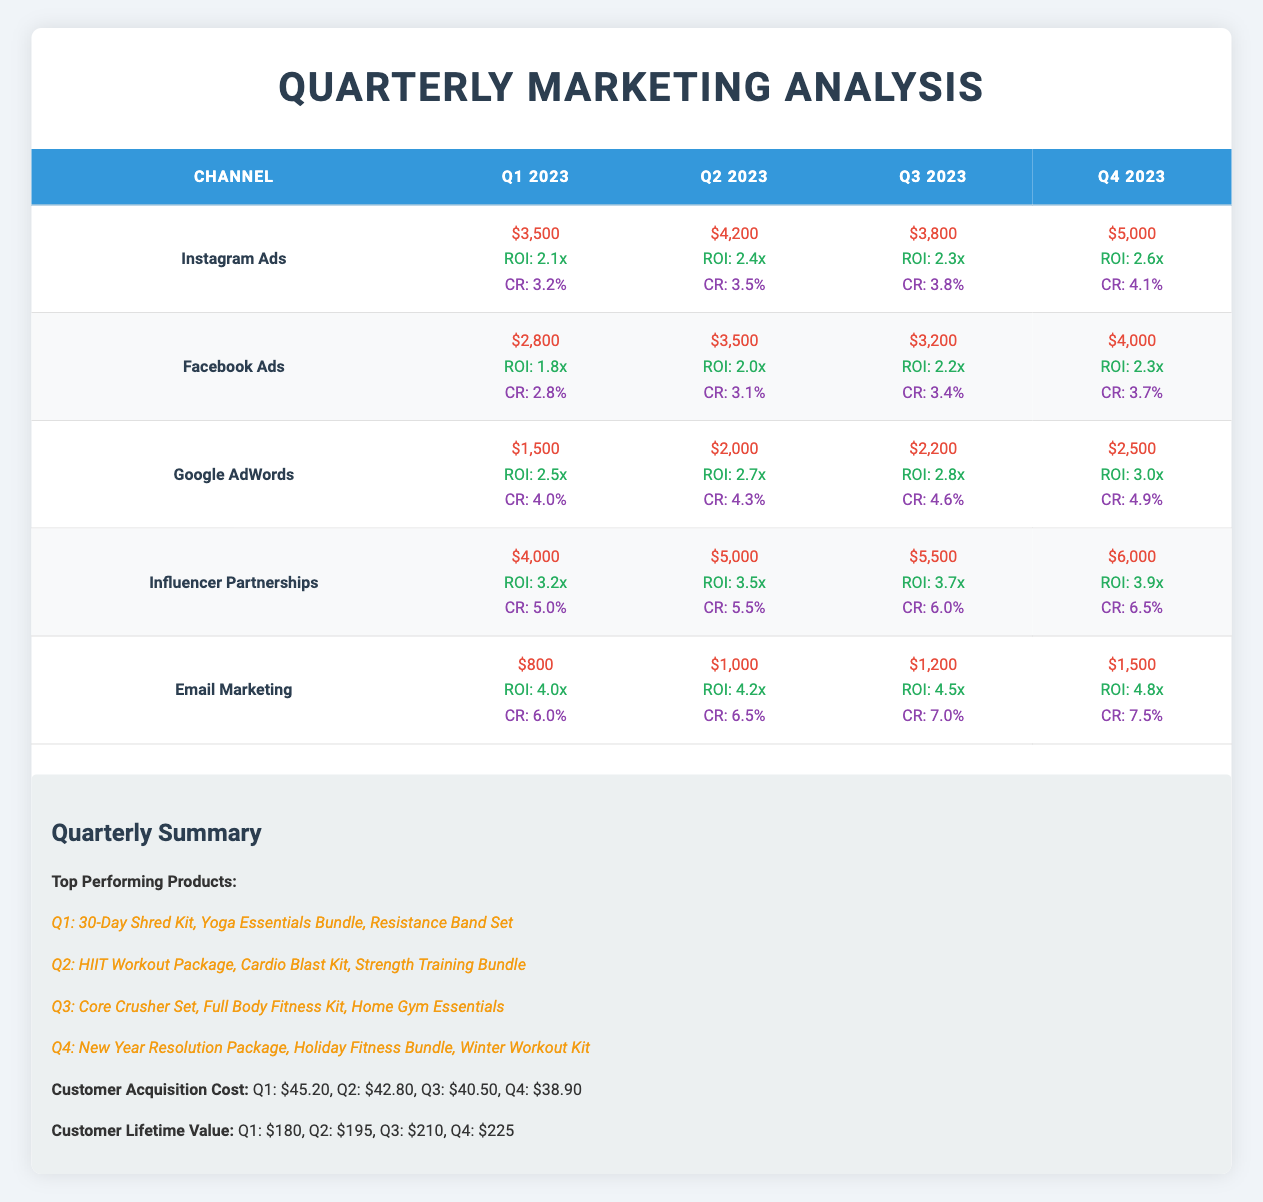What was the highest ROI achieved in Q4 2023 across all marketing channels? The highest ROI in Q4 2023 is found by examining the ROI column for Q4. The values are: Instagram Ads (2.6x), Facebook Ads (2.3x), Google AdWords (3.0x), Influencer Partnerships (3.9x), and Email Marketing (4.8x). The highest value is 4.8x from Email Marketing.
Answer: 4.8x Which marketing channel had the lowest conversion rate in Q1 2023? To find the lowest conversion rate in Q1 2023, we examine the conversion rates: Instagram Ads (3.2%), Facebook Ads (2.8%), Google AdWords (4.0%), Influencer Partnerships (5.0%), and Email Marketing (6.0%). The lowest rate is 2.8% from Facebook Ads.
Answer: 2.8% What is the total marketing expense for Influencer Partnerships over all four quarters? We sum the expenses for Influencer Partnerships: Q1 ($4,000) + Q2 ($5,000) + Q3 ($5,500) + Q4 ($6,000) equals $4,000 + $5,000 + $5,500 + $6,000 = $20,500.
Answer: $20,500 Did the customer acquisition cost decrease from Q1 to Q4? We check the customer acquisition costs: Q1 is $45.20 and Q4 is $38.90. Since $38.90 is less than $45.20, the cost did decrease.
Answer: Yes What is the average customer lifetime value over the four quarters? To calculate the average customer lifetime value, we sum the values for each quarter: $180 + $195 + $210 + $225 = $810. Dividing by 4 gives $810 / 4 = $202.5.
Answer: $202.5 Which marketing channel maintained the highest ROI across all quarters? We look for the highest ROI across all quarters for each channel: Instagram Ads (highest is 2.6x), Facebook Ads (2.3x), Google AdWords (3.0x), Influencer Partnerships (3.9x), and Email Marketing (4.8x). The highest is 4.8x from Email Marketing, indicating it consistently outperformed others.
Answer: Email Marketing In which quarter did Google AdWords exhibit the largest increase in ROI compared to the previous quarter? We compare the ROI for Google AdWords: Q1 (2.5x), Q2 (2.7x), Q3 (2.8x), and Q4 (3.0x). The largest increase is from Q2 (2.7x) to Q3 (2.8x), which is an increase of 0.1x.
Answer: Q2 to Q3 What was the total expense on Email Marketing for Q2 and Q3 combined? We add the expenses for Email Marketing in Q2 ($1,000) and Q3 ($1,200), resulting in $1,000 + $1,200 = $2,200.
Answer: $2,200 